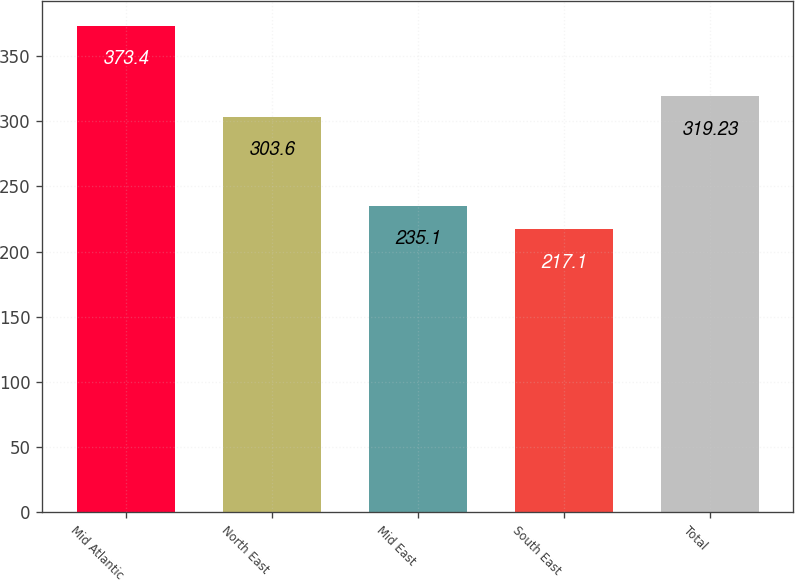<chart> <loc_0><loc_0><loc_500><loc_500><bar_chart><fcel>Mid Atlantic<fcel>North East<fcel>Mid East<fcel>South East<fcel>Total<nl><fcel>373.4<fcel>303.6<fcel>235.1<fcel>217.1<fcel>319.23<nl></chart> 